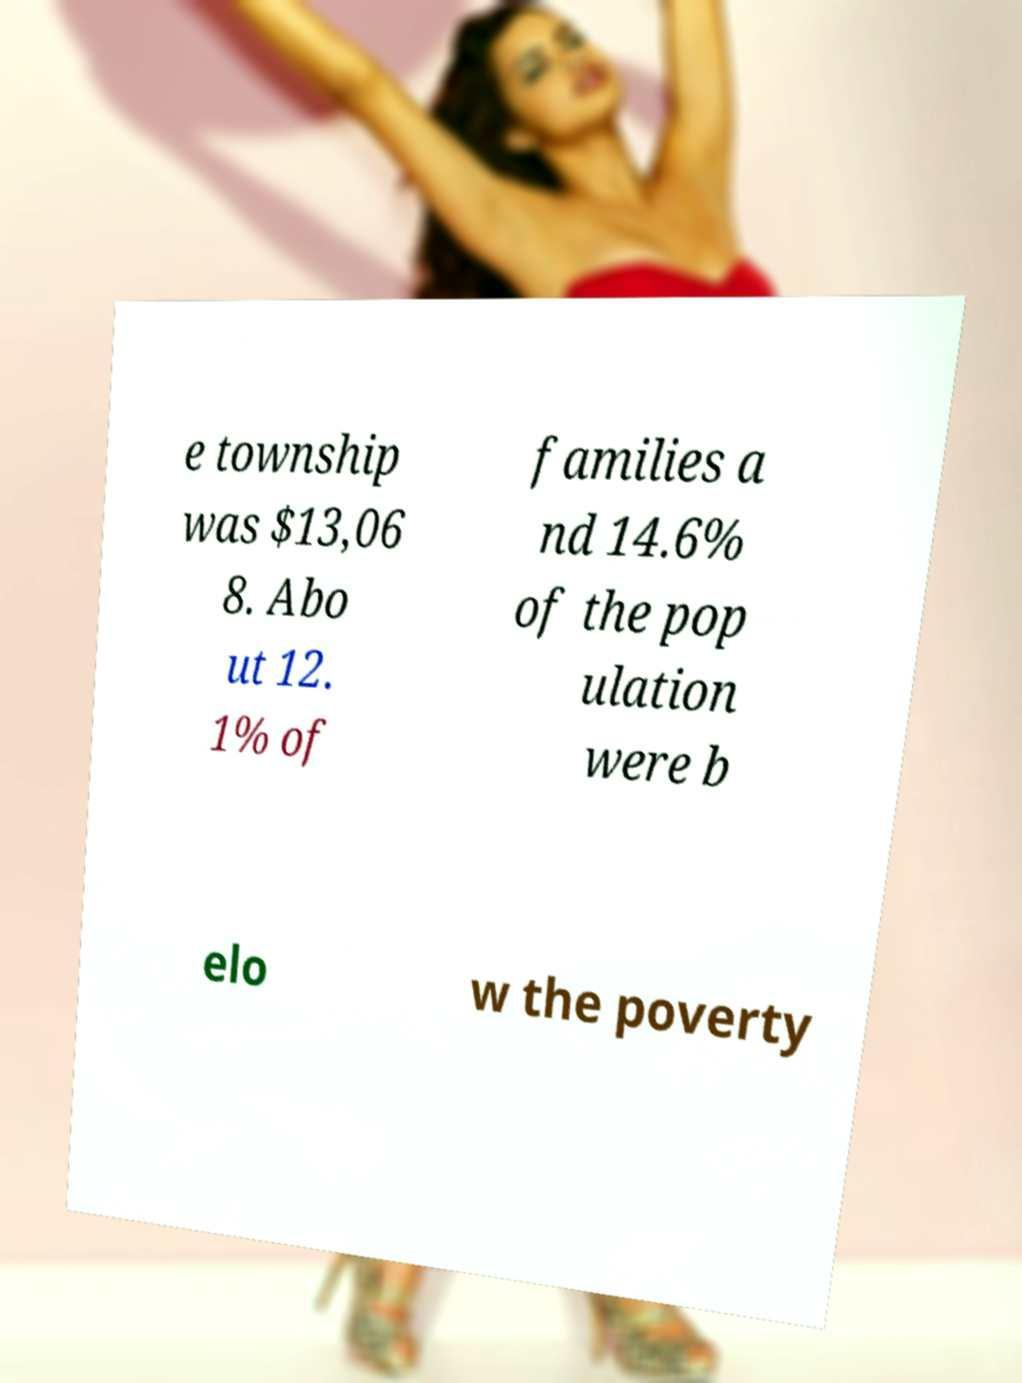Could you assist in decoding the text presented in this image and type it out clearly? e township was $13,06 8. Abo ut 12. 1% of families a nd 14.6% of the pop ulation were b elo w the poverty 